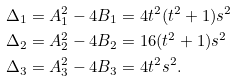<formula> <loc_0><loc_0><loc_500><loc_500>\Delta _ { 1 } & = A _ { 1 } ^ { 2 } - 4 B _ { 1 } = 4 t ^ { 2 } ( t ^ { 2 } + 1 ) s ^ { 2 } \\ \Delta _ { 2 } & = A _ { 2 } ^ { 2 } - 4 B _ { 2 } = 1 6 ( t ^ { 2 } + 1 ) s ^ { 2 } \\ \Delta _ { 3 } & = A _ { 3 } ^ { 2 } - 4 B _ { 3 } = 4 t ^ { 2 } s ^ { 2 } .</formula> 